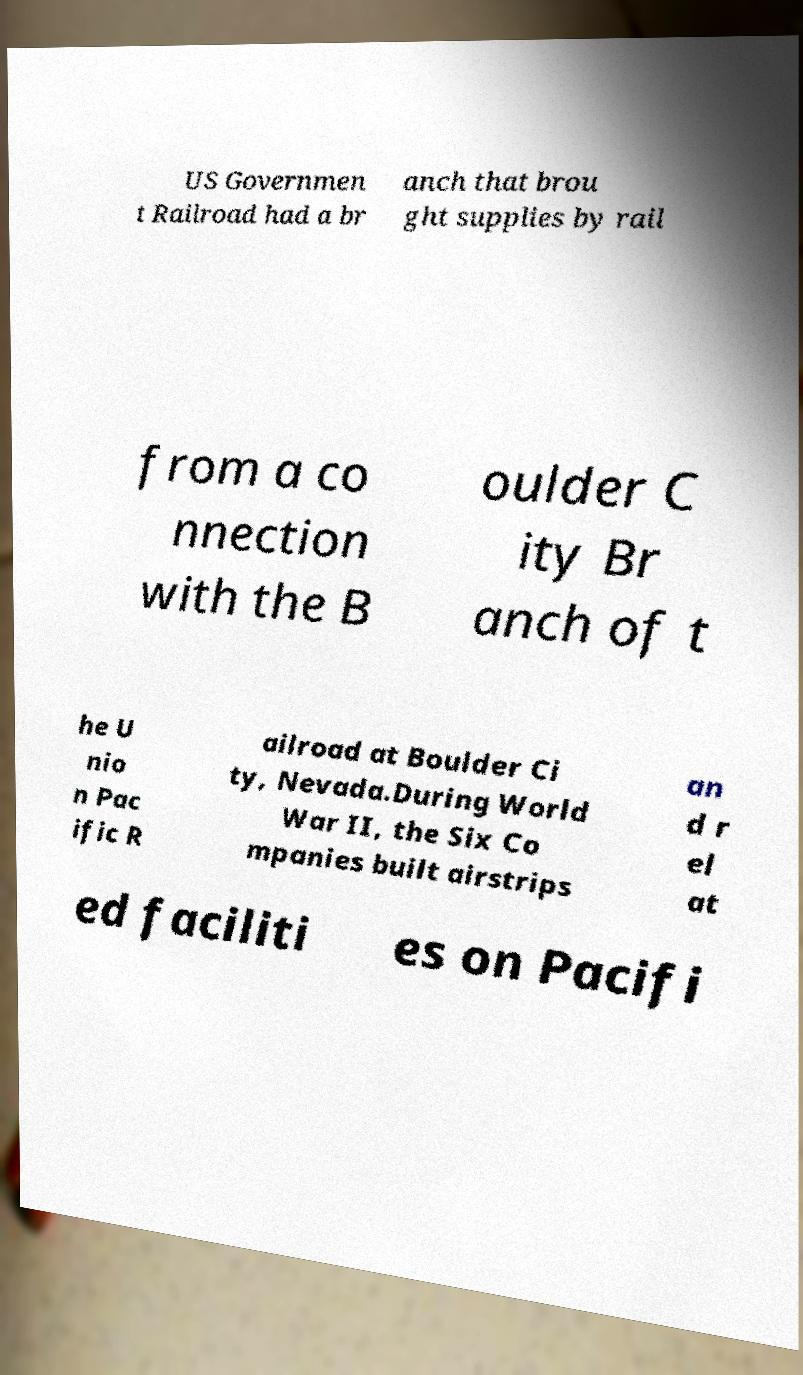Please identify and transcribe the text found in this image. US Governmen t Railroad had a br anch that brou ght supplies by rail from a co nnection with the B oulder C ity Br anch of t he U nio n Pac ific R ailroad at Boulder Ci ty, Nevada.During World War II, the Six Co mpanies built airstrips an d r el at ed faciliti es on Pacifi 